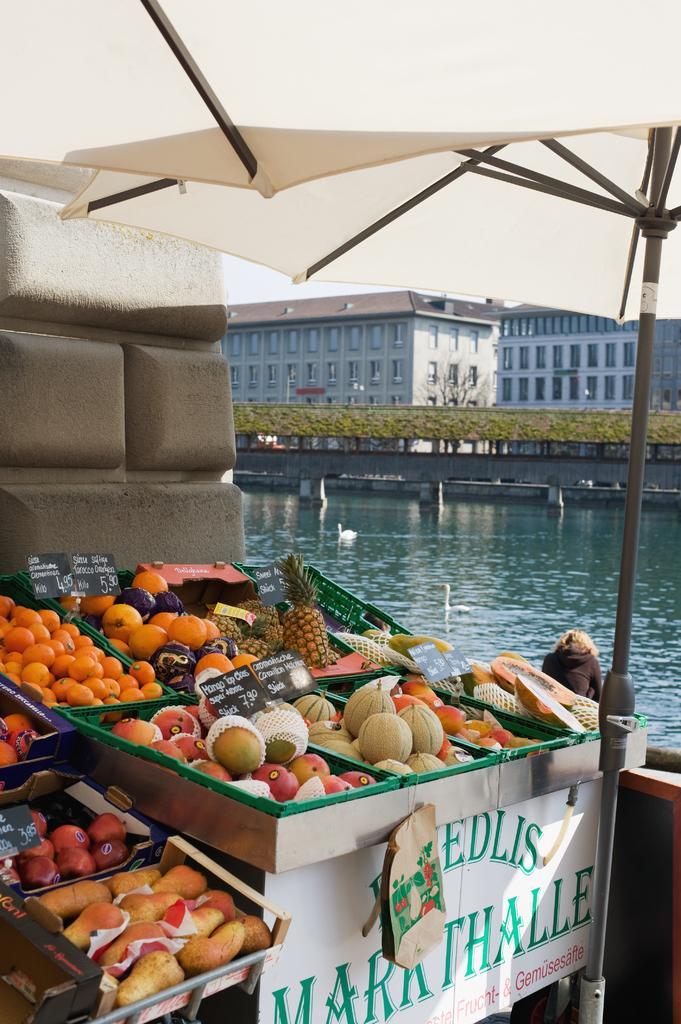Could you give a brief overview of what you see in this image? In the image we can see different varieties of fruits kept in the tray. Here we can see the poster and text on the poster. Here we can see the tent pole and the water. Here we can see the buildings and windows of the buildings. We can even see the ducks in the water. Here we can see planets and the sky. 